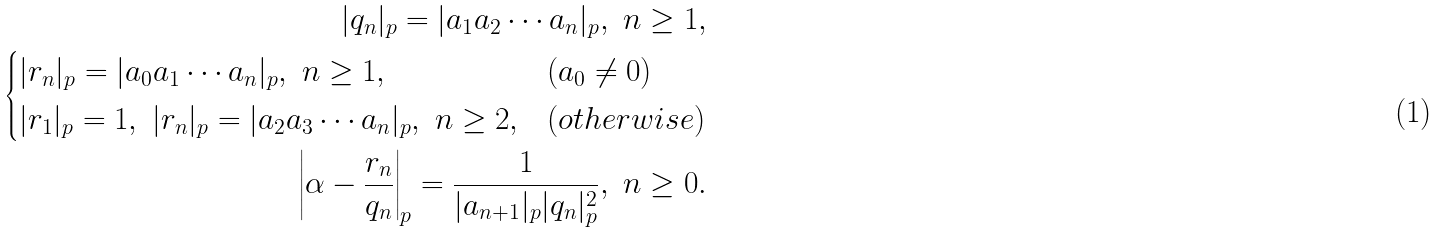<formula> <loc_0><loc_0><loc_500><loc_500>| q _ { n } | _ { p } = | a _ { 1 } a _ { 2 } \cdots a _ { n } | _ { p } , \ n \geq 1 , \\ \begin{cases} | r _ { n } | _ { p } = | a _ { 0 } a _ { 1 } \cdots a _ { n } | _ { p } , \ n \geq 1 , & ( a _ { 0 } \not = 0 ) \\ | r _ { 1 } | _ { p } = 1 , \ | r _ { n } | _ { p } = | a _ { 2 } a _ { 3 } \cdots a _ { n } | _ { p } , \ n \geq 2 , & ( o t h e r w i s e ) \end{cases} \\ \left | \alpha - \frac { r _ { n } } { q _ { n } } \right | _ { p } = \frac { 1 } { | a _ { n + 1 } | _ { p } | q _ { n } | _ { p } ^ { 2 } } , \ n \geq 0 .</formula> 